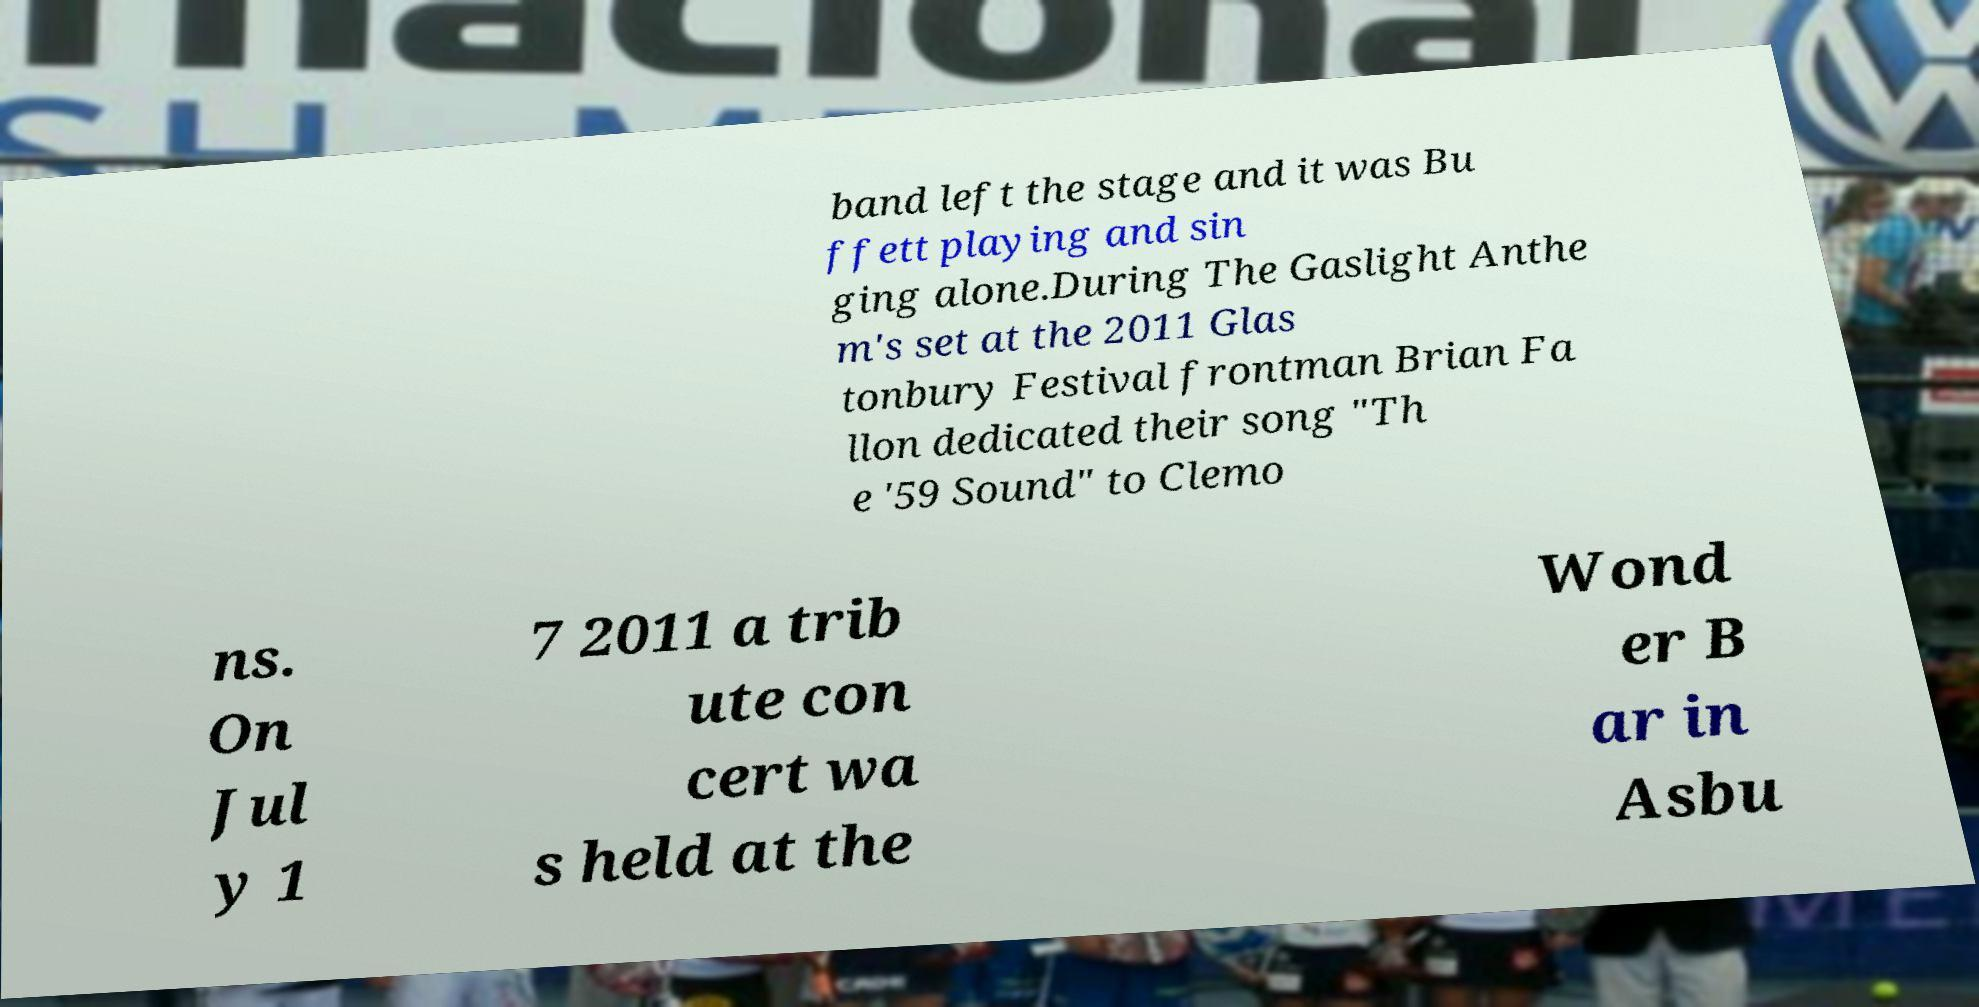Can you read and provide the text displayed in the image?This photo seems to have some interesting text. Can you extract and type it out for me? band left the stage and it was Bu ffett playing and sin ging alone.During The Gaslight Anthe m's set at the 2011 Glas tonbury Festival frontman Brian Fa llon dedicated their song "Th e '59 Sound" to Clemo ns. On Jul y 1 7 2011 a trib ute con cert wa s held at the Wond er B ar in Asbu 